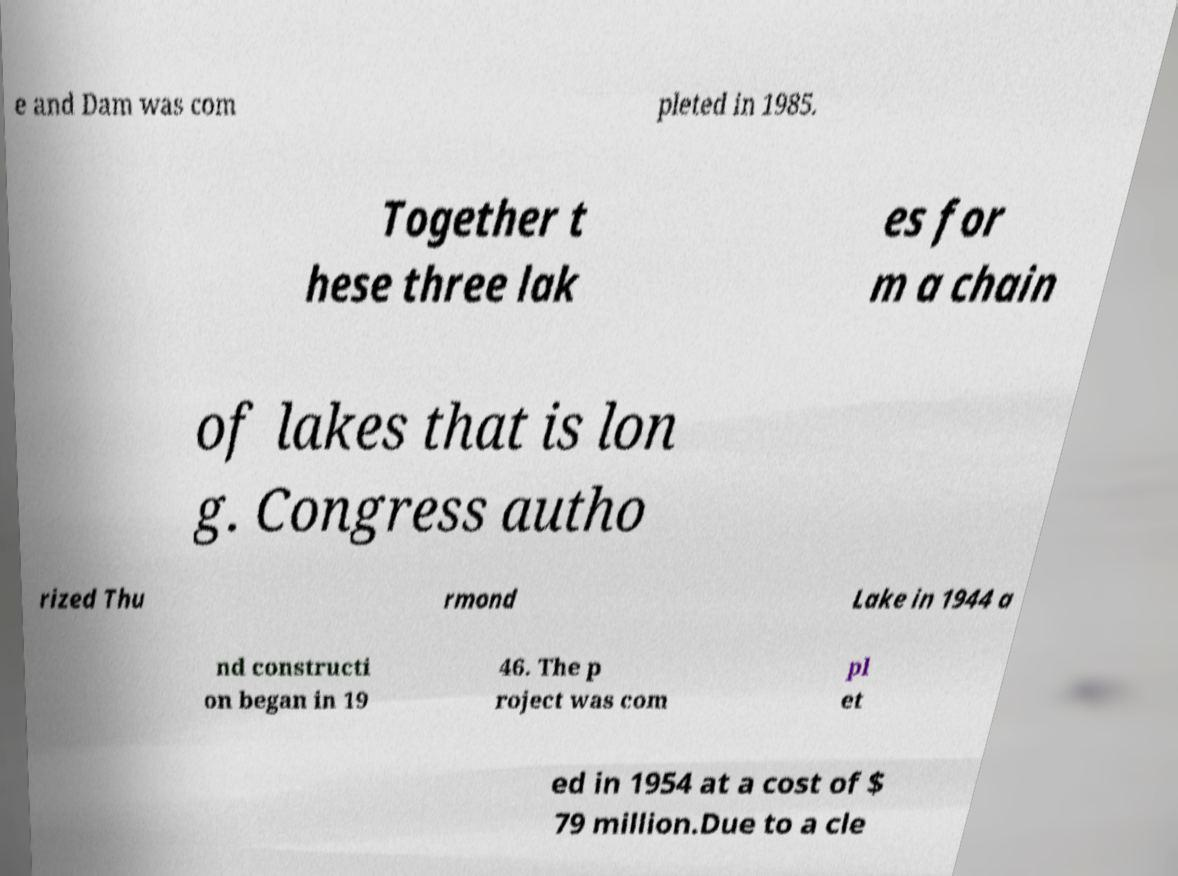Could you assist in decoding the text presented in this image and type it out clearly? e and Dam was com pleted in 1985. Together t hese three lak es for m a chain of lakes that is lon g. Congress autho rized Thu rmond Lake in 1944 a nd constructi on began in 19 46. The p roject was com pl et ed in 1954 at a cost of $ 79 million.Due to a cle 